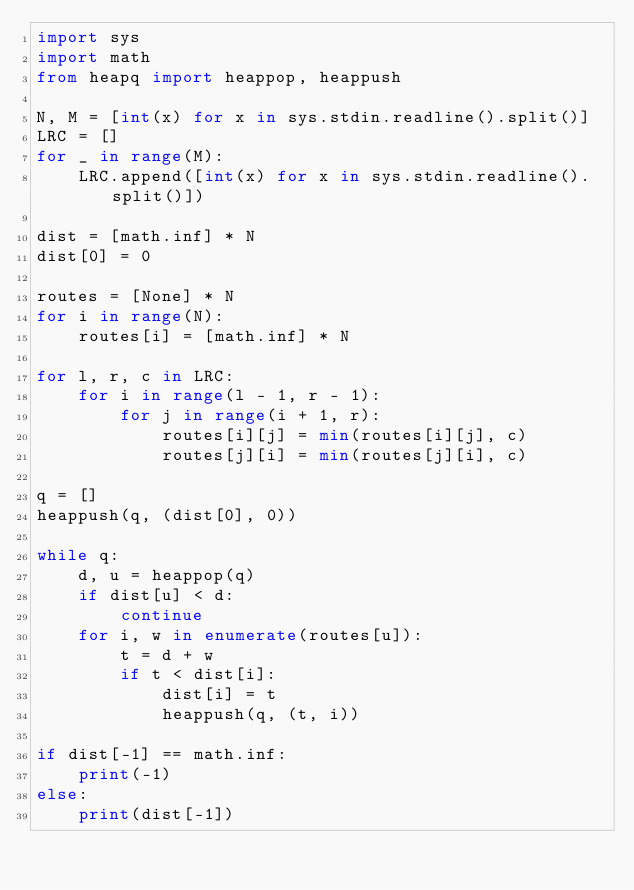Convert code to text. <code><loc_0><loc_0><loc_500><loc_500><_Python_>import sys
import math
from heapq import heappop, heappush

N, M = [int(x) for x in sys.stdin.readline().split()]
LRC = []
for _ in range(M):
    LRC.append([int(x) for x in sys.stdin.readline().split()])

dist = [math.inf] * N
dist[0] = 0

routes = [None] * N
for i in range(N):
    routes[i] = [math.inf] * N

for l, r, c in LRC:
    for i in range(l - 1, r - 1):
        for j in range(i + 1, r):
            routes[i][j] = min(routes[i][j], c)
            routes[j][i] = min(routes[j][i], c)

q = []
heappush(q, (dist[0], 0))

while q:
    d, u = heappop(q)
    if dist[u] < d:
        continue
    for i, w in enumerate(routes[u]):
        t = d + w
        if t < dist[i]:
            dist[i] = t
            heappush(q, (t, i))

if dist[-1] == math.inf:
    print(-1)
else:
    print(dist[-1])</code> 